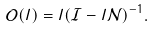Convert formula to latex. <formula><loc_0><loc_0><loc_500><loc_500>\mathcal { O } ( l ) = l ( \mathcal { I } - l \mathcal { N } ) ^ { - 1 } .</formula> 